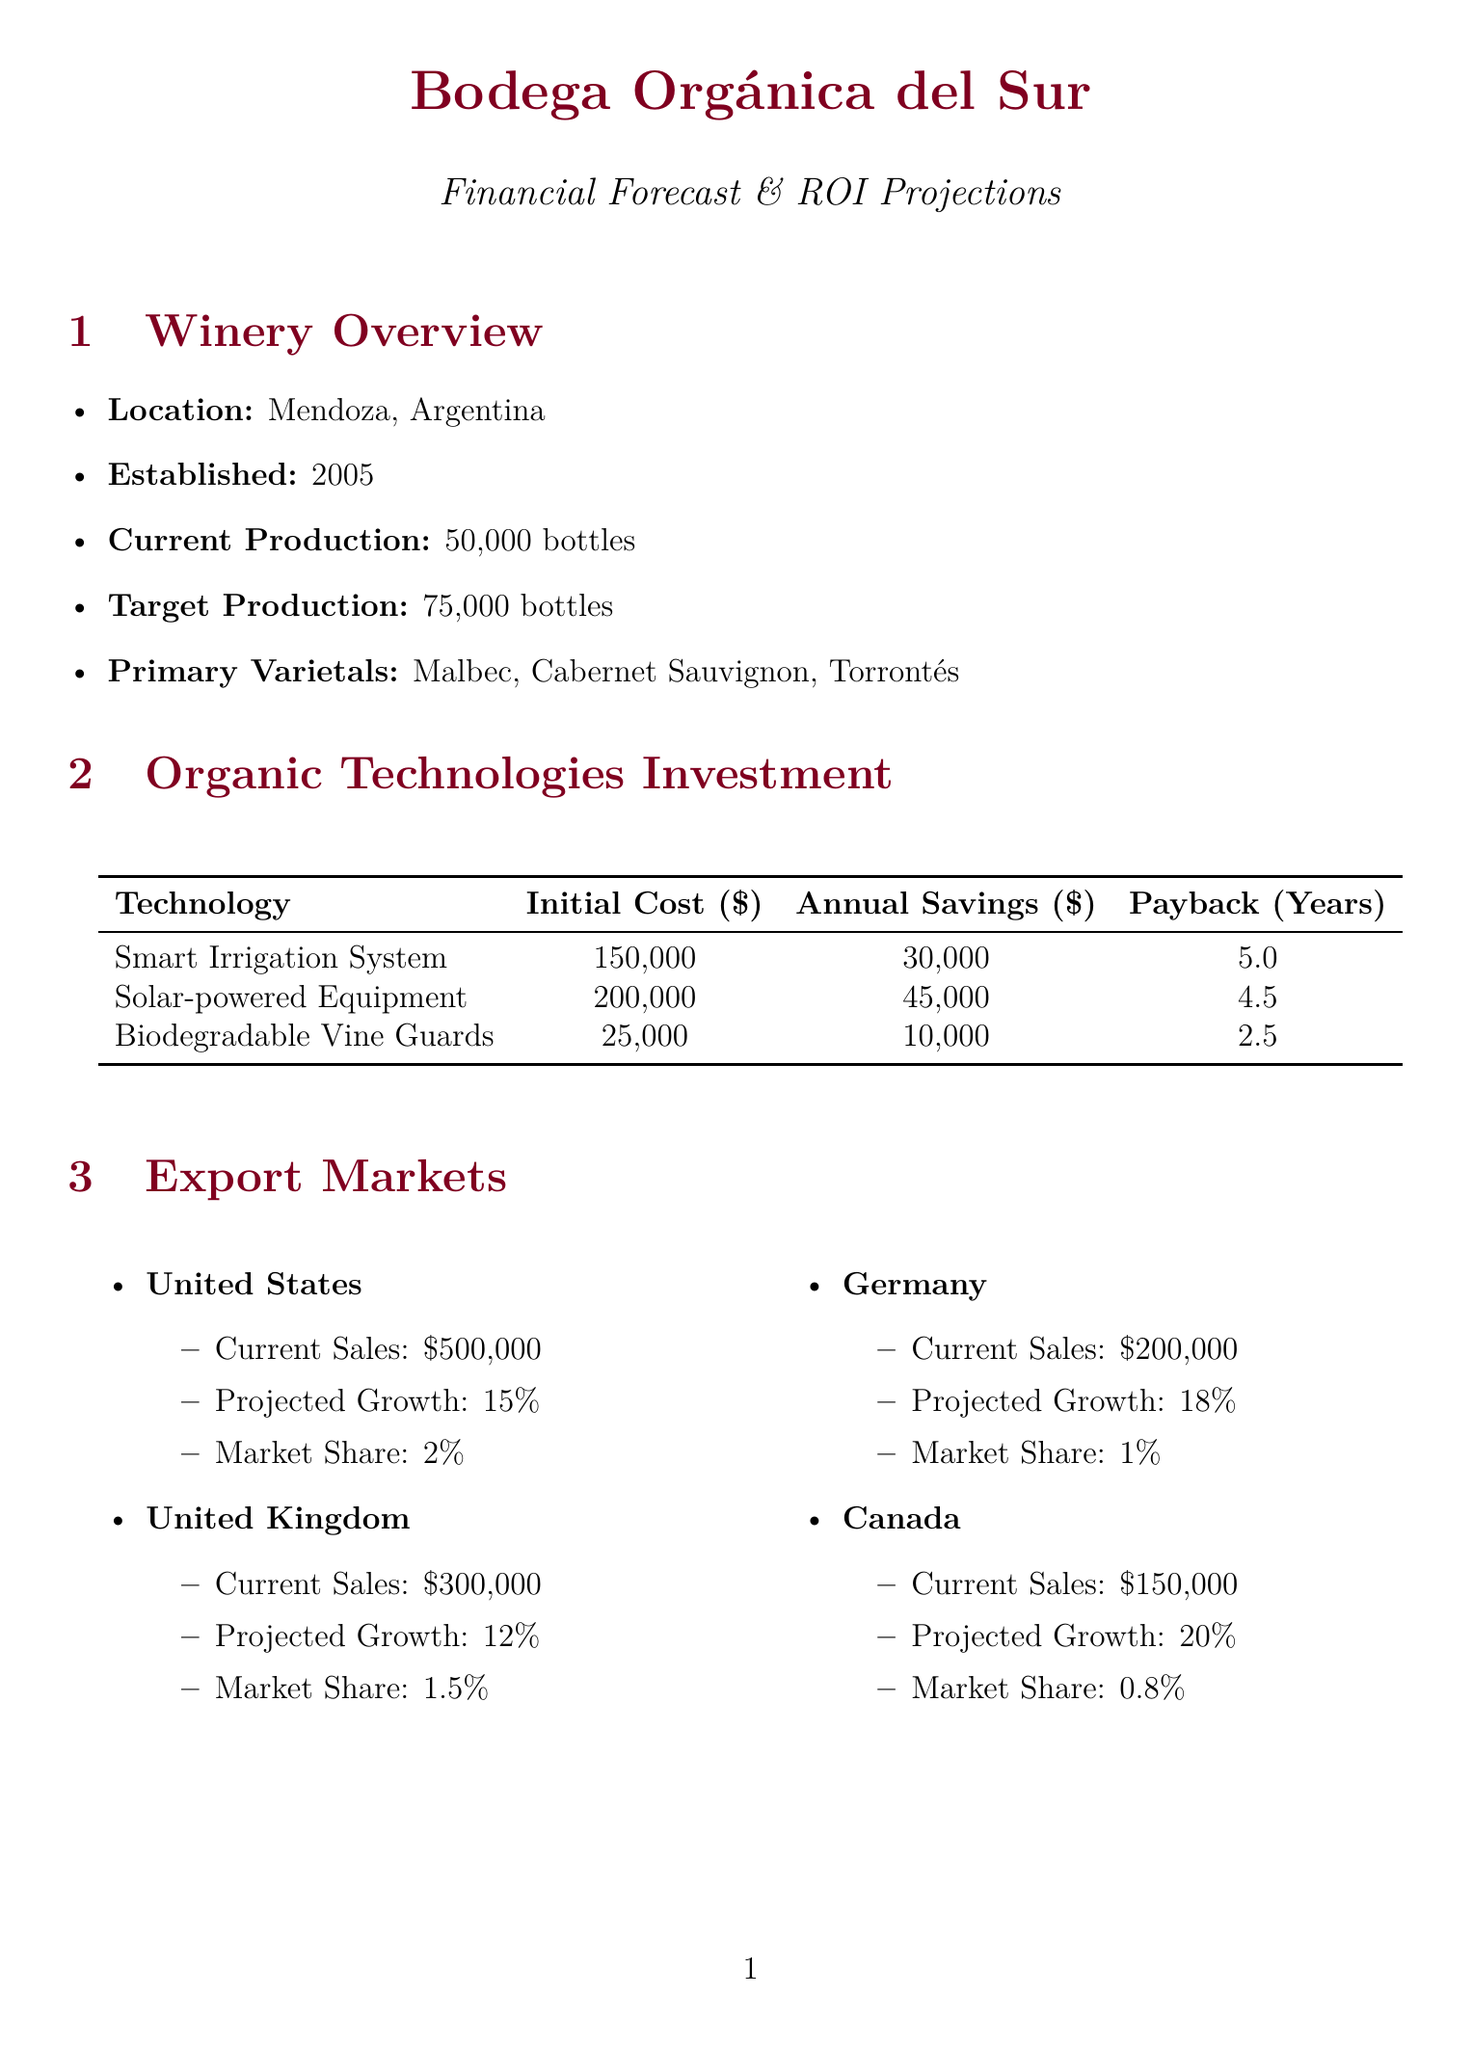what is the name of the winery? The name of the winery is mentioned in the document.
Answer: Bodega Orgánica del Sur what is the initial cost of the Smart Irrigation System? The document provides specific costs for each organic technology.
Answer: 150000 what is the projected revenue in year 5? The projected revenue for year 5 is indicated in the financial projections section.
Answer: 5005859 how much is the total investment for new organic technologies? The total investment is detailed in the ROI analysis section.
Answer: 375000 what is the projected growth rate for sales in Germany? The projected growth rate is given for each export market.
Answer: 0.18 how much is the annual savings from solar-powered winery equipment? Annual savings for each technology are listed in the organic technologies section.
Answer: 45000 what is the compliance cost for the USDA National Organic Program? The document lists compliance costs for each regulation.
Answer: 20000 what is the water usage reduction percentage? The sustainability metrics indicate the percentage of water usage reduction.
Answer: 30 which competitor has the highest market share? The competitive analysis provides market shares for each competitor.
Answer: Viñedos Orgánicos Uco 